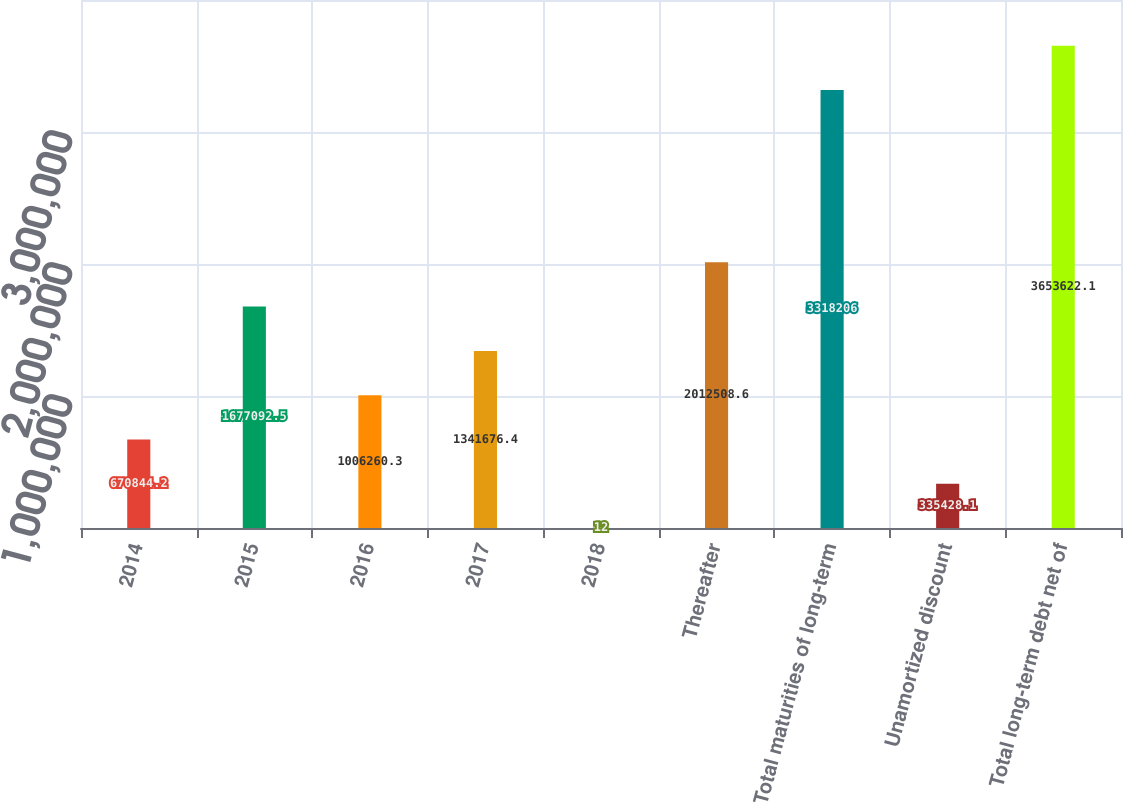Convert chart. <chart><loc_0><loc_0><loc_500><loc_500><bar_chart><fcel>2014<fcel>2015<fcel>2016<fcel>2017<fcel>2018<fcel>Thereafter<fcel>Total maturities of long-term<fcel>Unamortized discount<fcel>Total long-term debt net of<nl><fcel>670844<fcel>1.67709e+06<fcel>1.00626e+06<fcel>1.34168e+06<fcel>12<fcel>2.01251e+06<fcel>3.31821e+06<fcel>335428<fcel>3.65362e+06<nl></chart> 